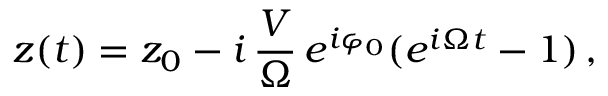Convert formula to latex. <formula><loc_0><loc_0><loc_500><loc_500>z ( t ) = z _ { 0 } - i \, \frac { V } { \Omega } \, e ^ { i \varphi _ { 0 } } ( e ^ { i \Omega t } - 1 ) \, ,</formula> 